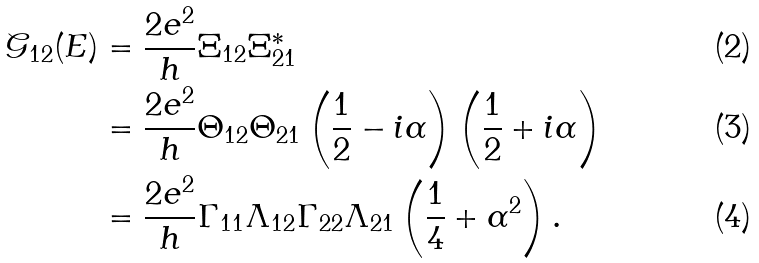Convert formula to latex. <formula><loc_0><loc_0><loc_500><loc_500>\mathcal { G } _ { 1 2 } ( E ) & = \frac { 2 e ^ { 2 } } { h } \Xi _ { 1 2 } \Xi _ { 2 1 } ^ { \ast } \\ & = \frac { 2 e ^ { 2 } } { h } \Theta _ { 1 2 } \Theta _ { 2 1 } \left ( \frac { 1 } { 2 } - i \alpha \right ) \left ( \frac { 1 } { 2 } + i \alpha \right ) \\ & = \frac { 2 e ^ { 2 } } { h } \Gamma _ { 1 1 } \Lambda _ { 1 2 } \Gamma _ { 2 2 } \Lambda _ { 2 1 } \left ( \frac { 1 } { 4 } + \alpha ^ { 2 } \right ) .</formula> 